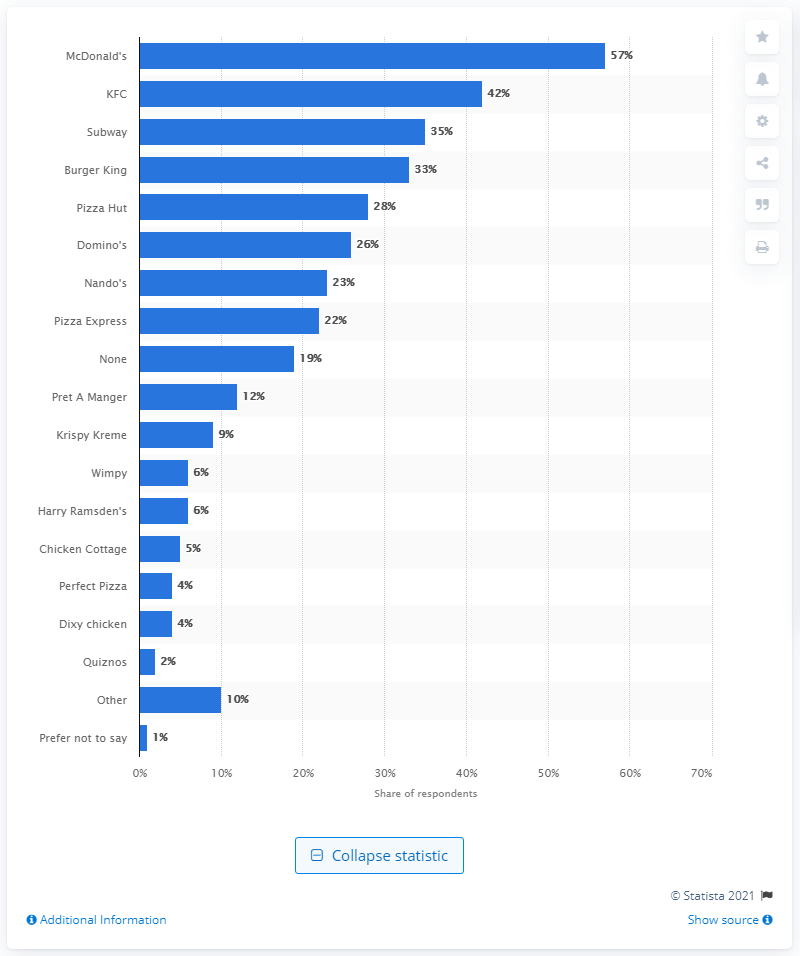Draw attention to some important aspects in this diagram. It is widely established that McDonald's is the most popular fast food chain in the United Kingdom. 